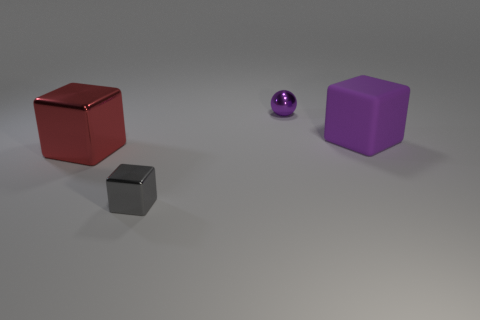Does the lighting seem to be coming from a particular direction? Yes, the lighting appears to be coming from the upper left side of the image. You can tell by the way the shadows are cast on the floor; they extend towards the bottom right, indicating the light source is opposite to them. 